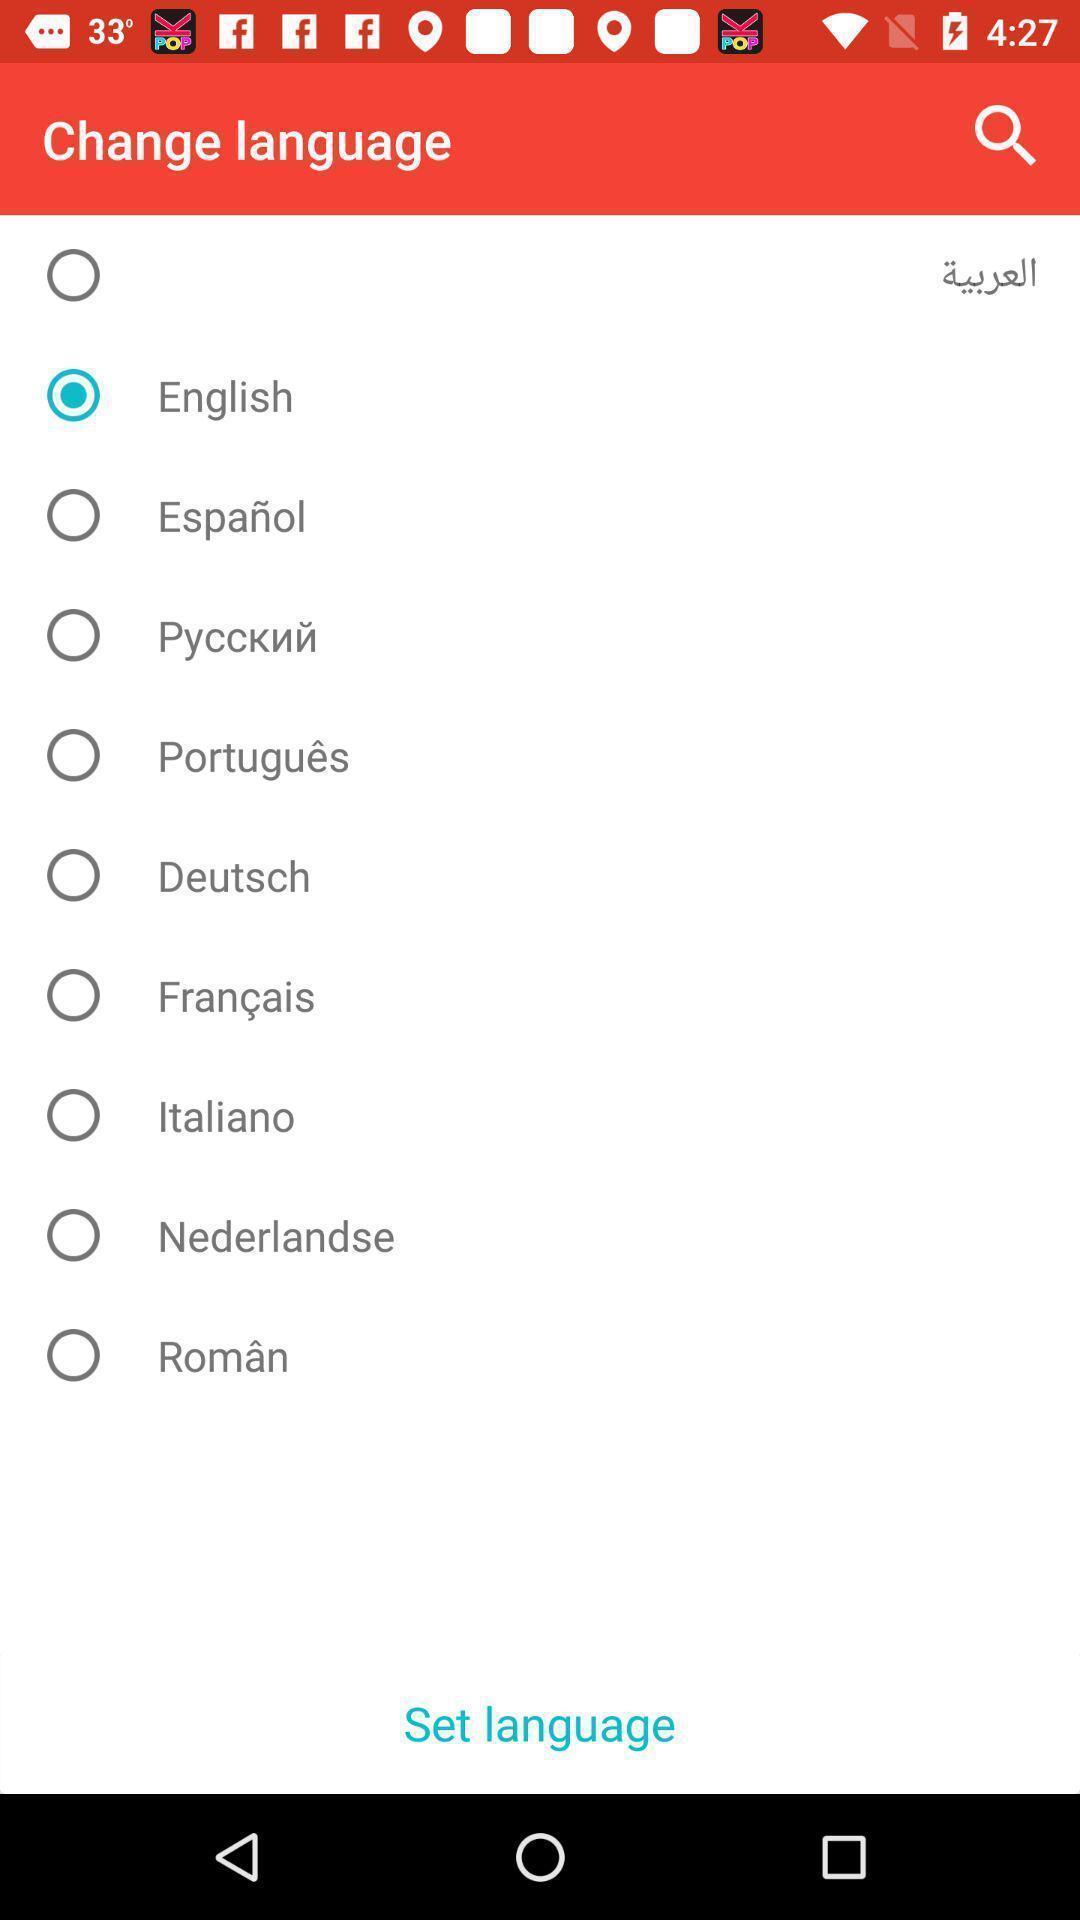Provide a description of this screenshot. Page shows multiple languages to choose. 